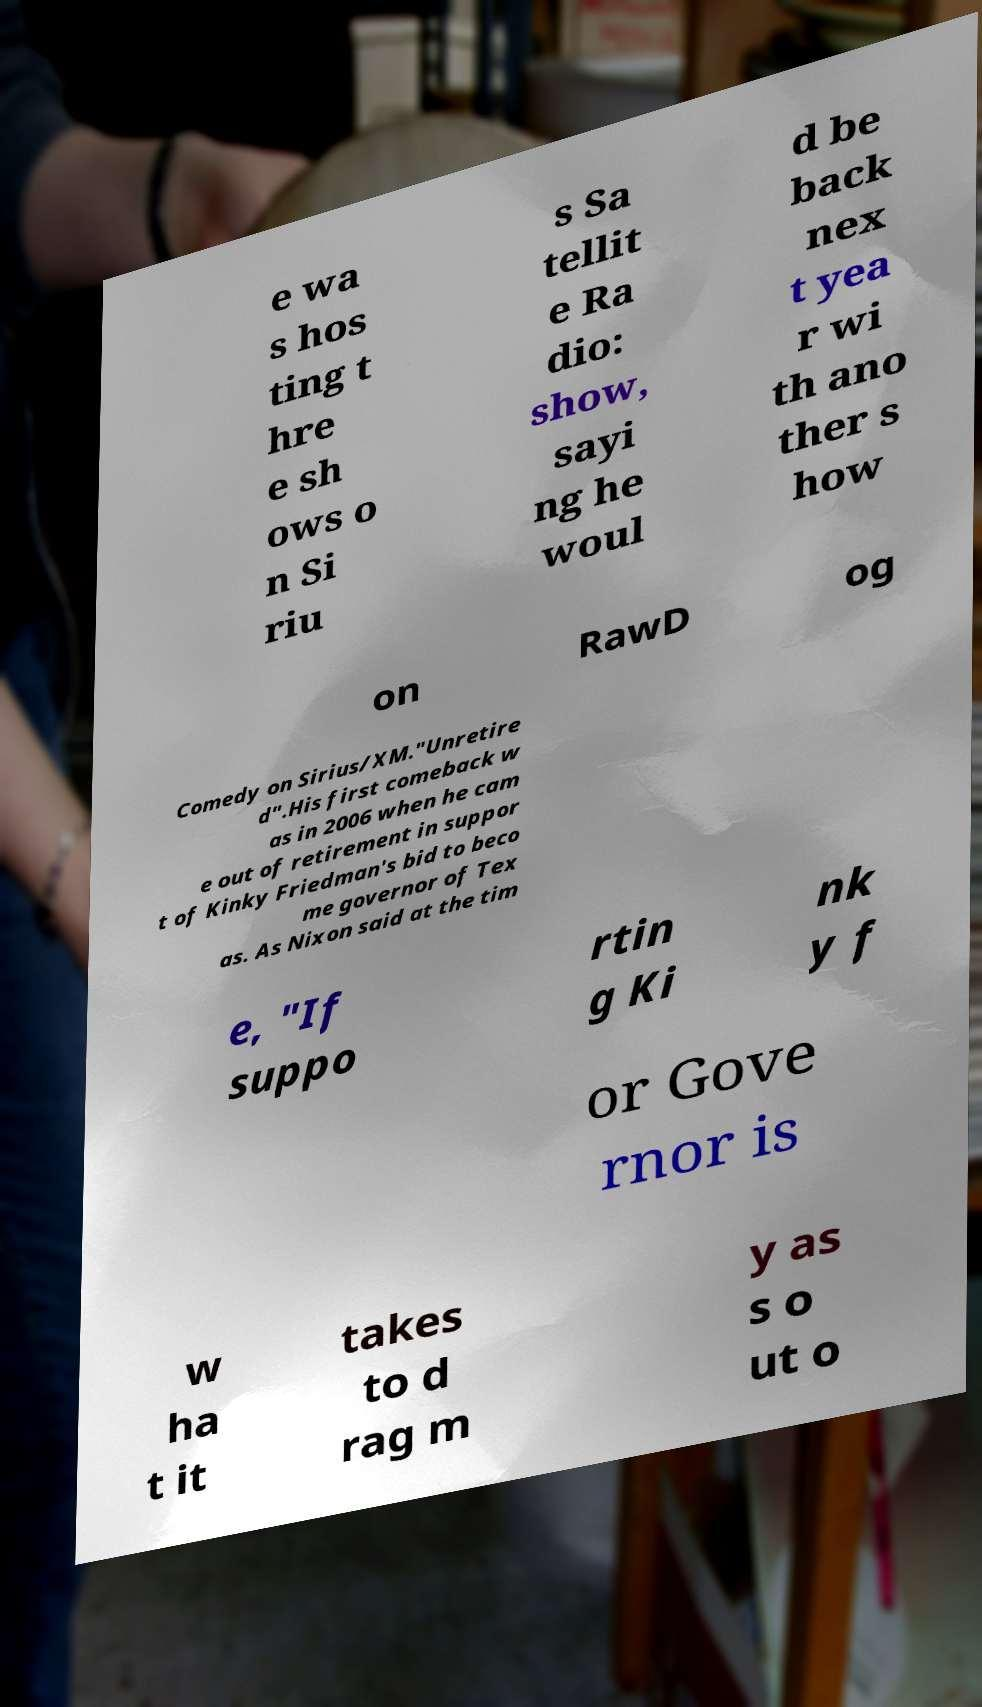What messages or text are displayed in this image? I need them in a readable, typed format. e wa s hos ting t hre e sh ows o n Si riu s Sa tellit e Ra dio: show, sayi ng he woul d be back nex t yea r wi th ano ther s how on RawD og Comedy on Sirius/XM."Unretire d".His first comeback w as in 2006 when he cam e out of retirement in suppor t of Kinky Friedman's bid to beco me governor of Tex as. As Nixon said at the tim e, "If suppo rtin g Ki nk y f or Gove rnor is w ha t it takes to d rag m y as s o ut o 